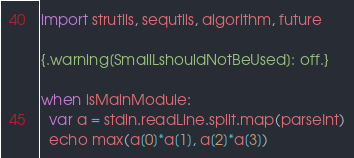Convert code to text. <code><loc_0><loc_0><loc_500><loc_500><_Nim_>import strutils, sequtils, algorithm, future

{.warning[SmallLshouldNotBeUsed]: off.}

when isMainModule:
  var a = stdin.readLine.split.map(parseInt)
  echo max(a[0]*a[1], a[2]*a[3])</code> 